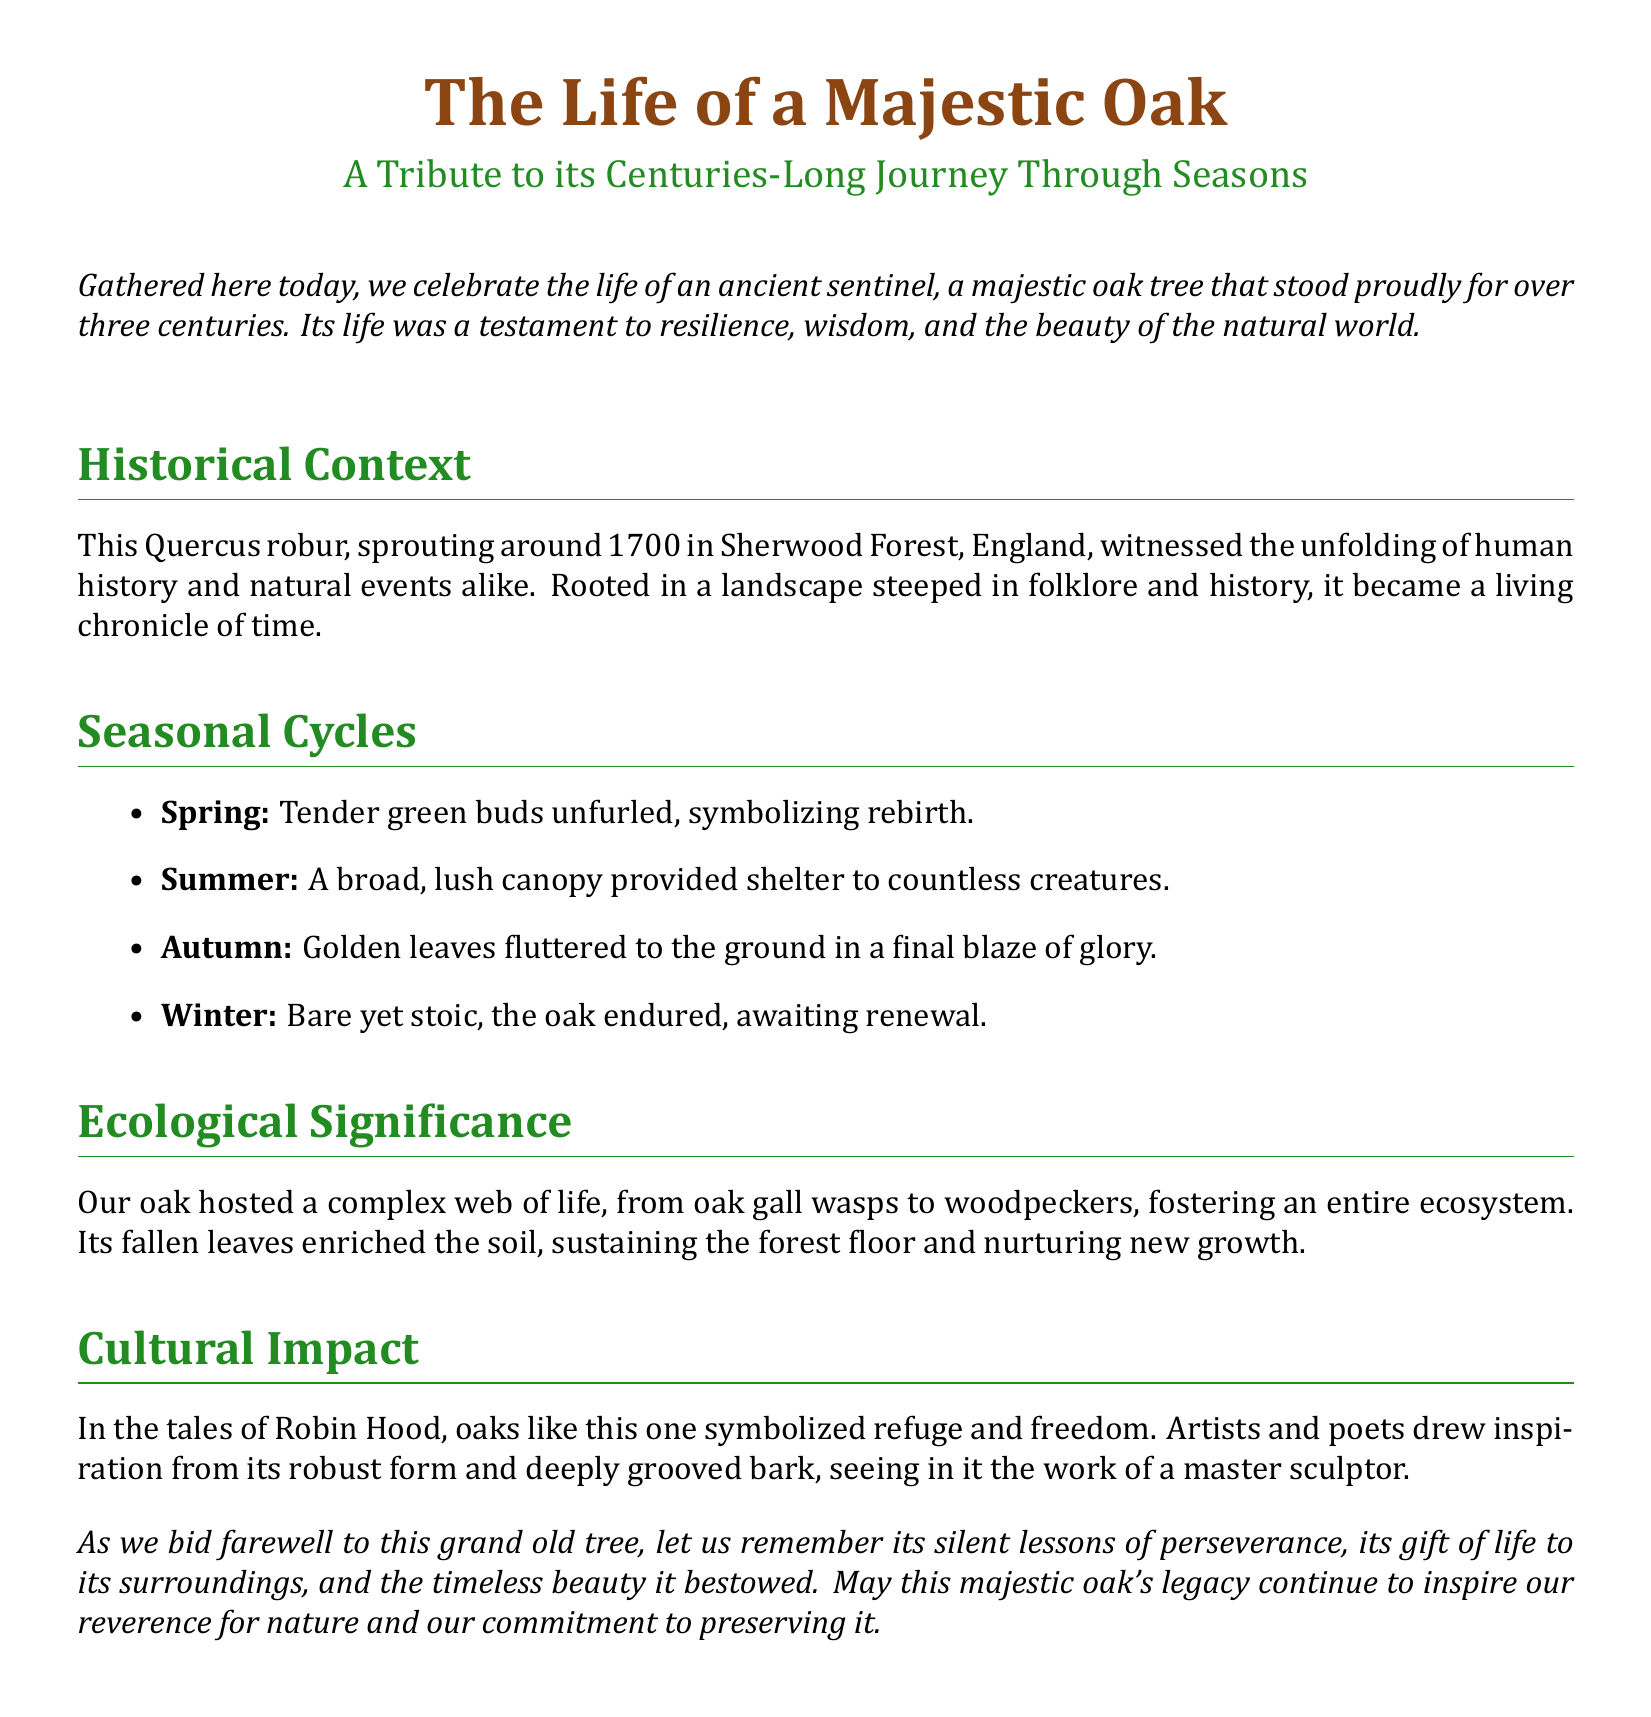What is the species of the tree? The document specifies that the tree is a Quercus robur.
Answer: Quercus robur In what year did the oak sprout? The document states that the oak tree sprouted around 1700.
Answer: 1700 What forest was the oak tree located in? The document refers to Sherwood Forest as the location of the oak tree.
Answer: Sherwood Forest How many centuries did the oak live? The document mentions that the oak stood proudly for over three centuries.
Answer: Three centuries Which season is associated with rebirth? The document links spring to the symbol of rebirth.
Answer: Spring What literary figure is mentioned in relation to the oak? The oak is connected to the tales of Robin Hood.
Answer: Robin Hood What ecological role did the oak play? The document indicates that the oak hosted a complex web of life.
Answer: Complex web of life Which color represents the oak in the document's title? The document uses oak brown to symbolize the majestic oak in the title.
Answer: Oak brown What lesson does the eulogy emphasize about the oak? The document highlights silent lessons of perseverance from the oak.
Answer: Perseverance 